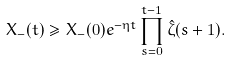<formula> <loc_0><loc_0><loc_500><loc_500>X _ { - } ( t ) \geq X _ { - } ( 0 ) e ^ { - \eta t } \prod _ { s = 0 } ^ { t - 1 } \hat { \zeta } ( s + 1 ) .</formula> 